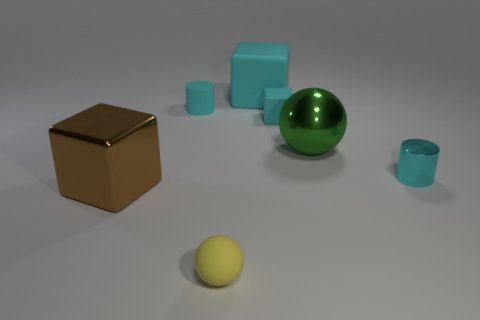Subtract all cyan blocks. How many blocks are left? 1 Add 1 cyan objects. How many objects exist? 8 Subtract all cyan cubes. How many cubes are left? 1 Subtract all cylinders. How many objects are left? 5 Subtract 1 cylinders. How many cylinders are left? 1 Subtract all gray blocks. How many brown balls are left? 0 Subtract all small yellow rubber balls. Subtract all brown cubes. How many objects are left? 5 Add 4 shiny things. How many shiny things are left? 7 Add 7 big cyan rubber cylinders. How many big cyan rubber cylinders exist? 7 Subtract 0 purple cubes. How many objects are left? 7 